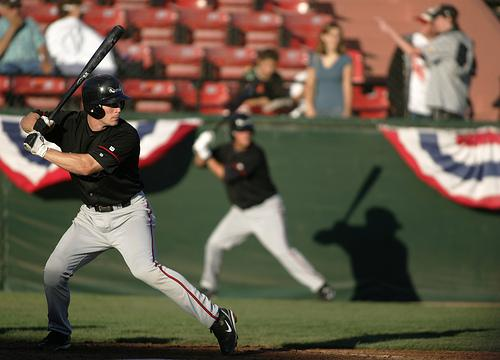Identify an object in the image that represents patriotism. A red, white, and blue banner on a wall. Rate the image quality based on the clarity of described objects (1-5). 4, most objects are clear but there's a blurry patriotic banner. Combine the actions of the baseball player, the man explaining something away from the game, and the woman watching the game into one sentence. The baseball player is ready to bat while a man explains something away from the game, and a woman watches the baseball game intently. List three objects in the image that are sports-related and their corresponding colors. Black baseball helmet, black bat in man's hands, black Nike cleat on man. How many spectators are mentioned in the image description and what are they wearing? Three spectators: woman in a grey shirt, woman in a blue dress, and man pointing to his left. What is the color of the seats in the stands and what are two people doing near these seats? The seats are red and two people are talking near them. In a few words, summarize the atmosphere and sentiment of the image. A lively and engaging baseball match with spectators and players. In a simple sentence, describe what the baseball player is doing. The baseball player is getting ready to bat. Count the number of people mentioned in the image description. There are six people mentioned in the image description. Identify the main sporting activity depicted in the image. The main sporting activity depicted is baseball. Is there a baseball player holding a white bat? There are multiple mentions of a baseball bat in the image, but they are all described as black, not white. Is there a dog on the grass in the baseball field? Although there is mention of grass on a baseball field in the image, there is no mention of a dog or any other animals being present. Please detect any anomalies in the image related to the baseball game. No significant anomalies found. Is there any empty seat visible in the stands? Yes, there are a couple of empty stadium seats visible. Can you find a woman wearing a red dress standing in the image? There is a woman in the image wearing a dress, but it is mentioned as a blue dress, not red. Is the man at coordinates X:408 Y:12 paying attention to the game? No, he is explaining something away from the game. Assess the quality of the image with regards to blurriness. The overall image is clear, but there is a blurry patriotic banner. Are the baseball players waiting for their turn to hit the ball? Yes, the players are waiting to hit the ball. Are the baseball players wearing any protective gear? If yes, mention the gear. Yes, they are wearing helmets. Describe the main action being performed by the baseball player in the image. The baseball player is ready to bat. Describe the attributes of the helmet on the man's head. The helmet is black and shiny. What type of footwear is the man wearing a black shirt and white pants wearing? A black nike cleat. Is there a man wearing a yellow helmet in the image? There is a mention of a helmet on a man's head, but it is specified as a black shiny baseball helmet, not yellow. Identify the object with the position X:212 Y:299. A black nike cleat on a man. Can you find a banner with green and yellow stripes on the wall? No, it's not mentioned in the image. Which object has the following description: "a green wall at a baseball field"? coordinates X:0 Y:107, Width:498, Height:498. What kind of interaction can be observed between the man pointing to his left and the woman with a grey shirt? They seem to be talking or having a discussion. Are there any visible text or numbers in the image for OCR detection? No text or numbers visible. What is the color of the woman's shirt at coordinates X:320 Y:24? Grey. Which option correctly identifies the object at coordinates X:17 Y:15? A) Baseball glove, B) Baseball bat, C) Baseball cap B) Baseball bat Do you see any blue seats in the stands? There are seats mentioned in the image, but they are described as red seats in the stands, not blue. What is the prominent color of the banner at coordinates X:376 Y:121? Red, white, and blue. What emotion is conveyed by the image with a baseball player ready to bat? Anticipation or excitement. What is the color of the seats in the stands? The seats in the stands are red. What is the woman standing at coordinates X:296 Y:20 watching? She is watching the baseball game. Identify the woman wearing a blue dress in the image. coordinates X:303 Y:19, Width:54, Height:54. 